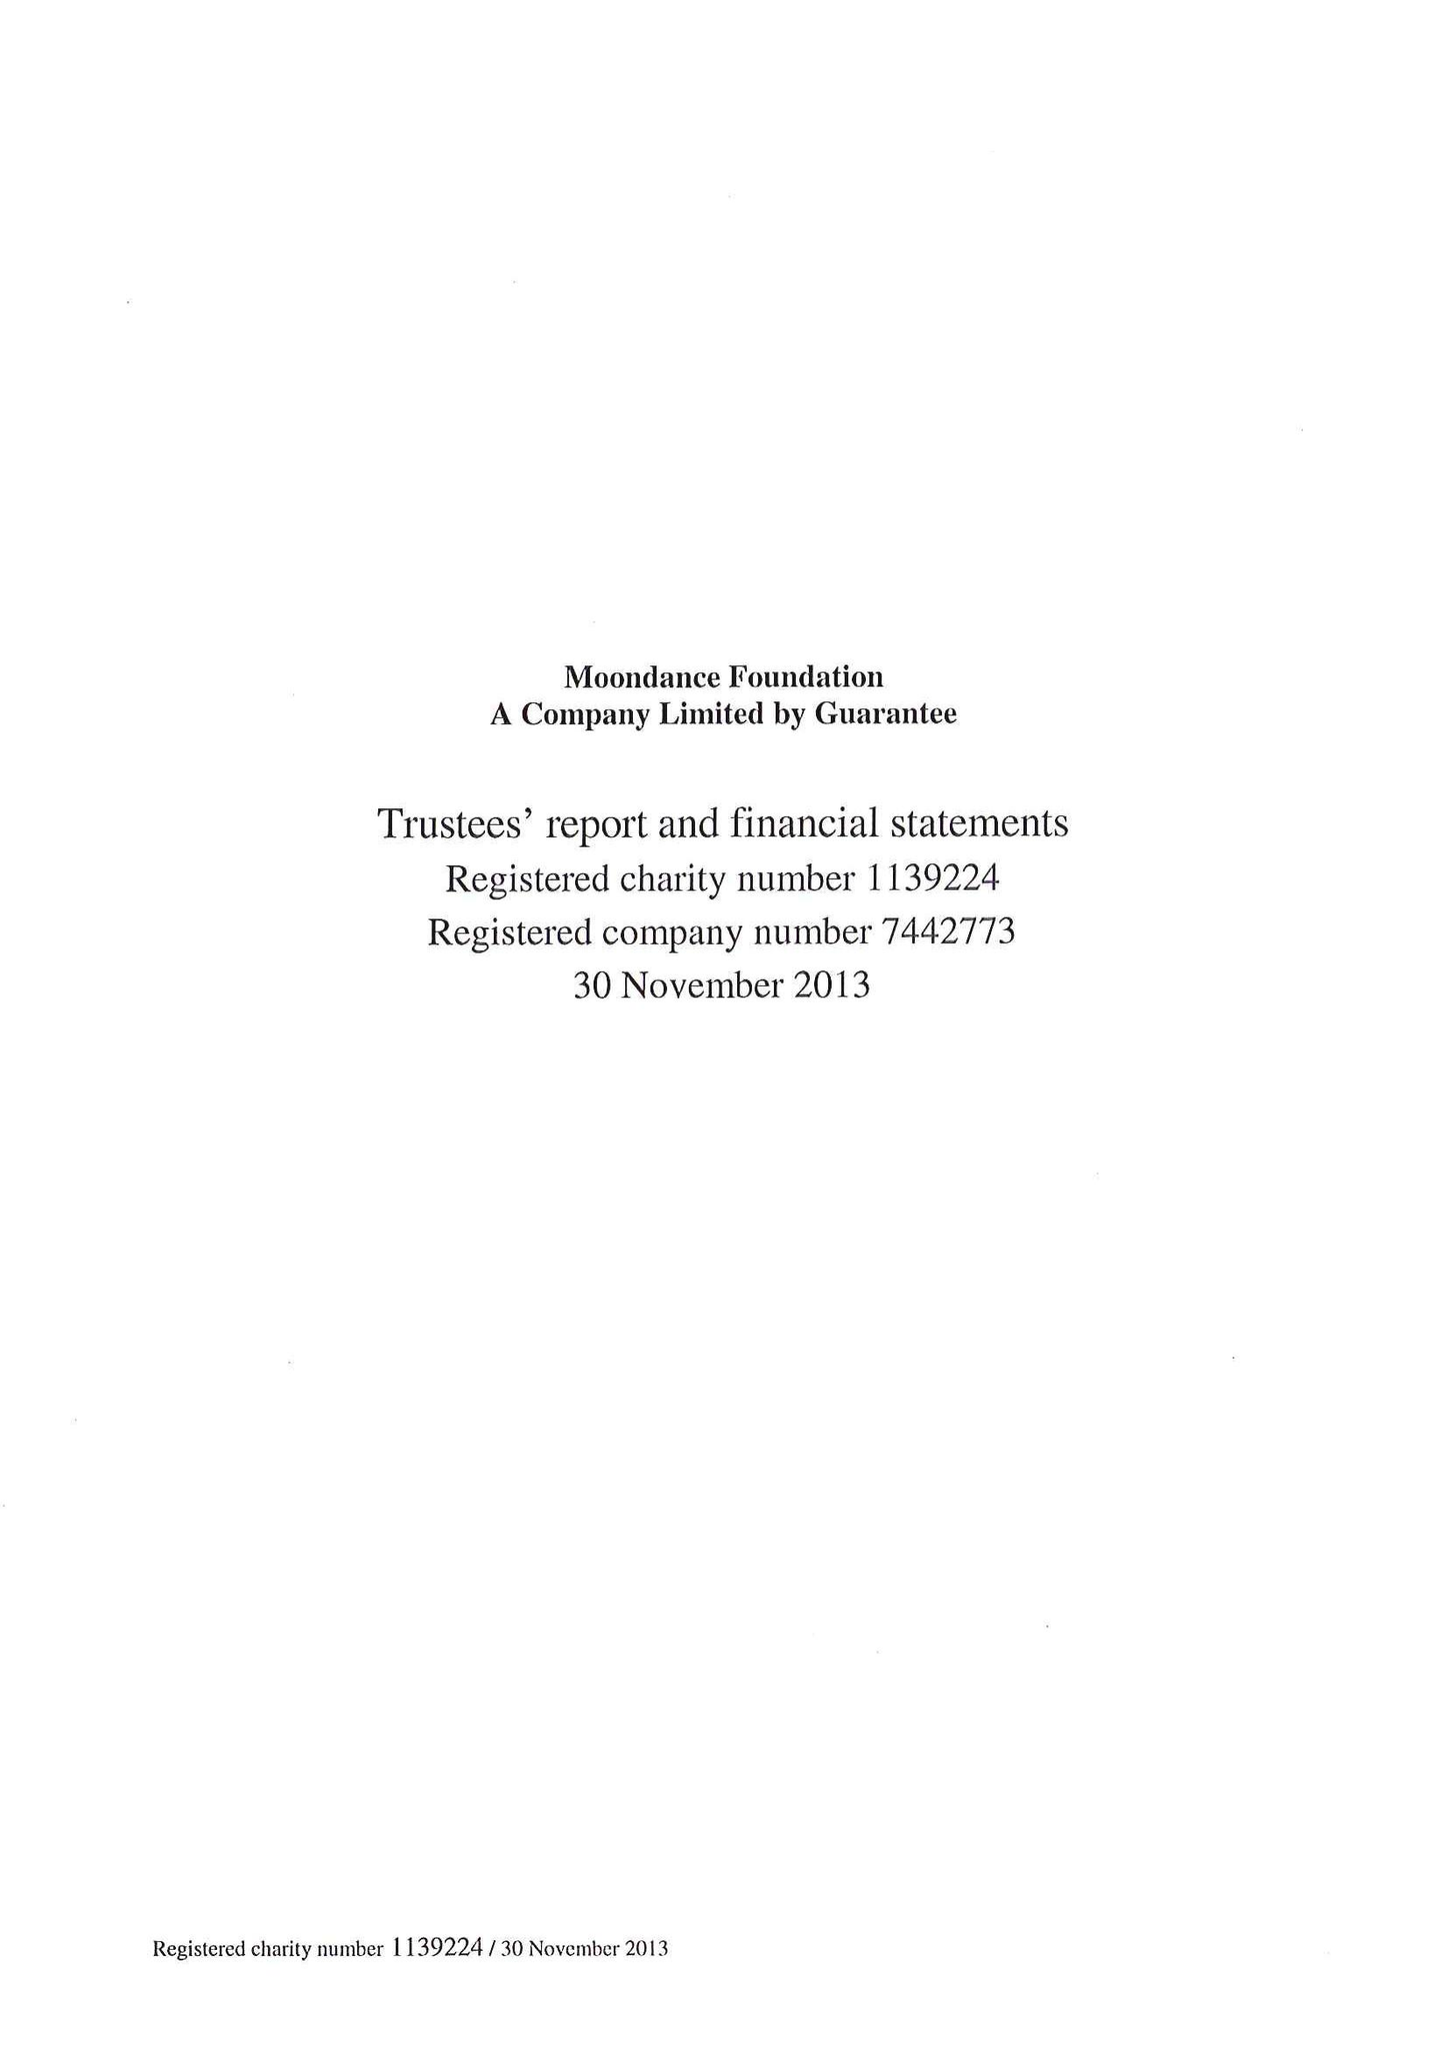What is the value for the address__post_town?
Answer the question using a single word or phrase. NEWPORT 